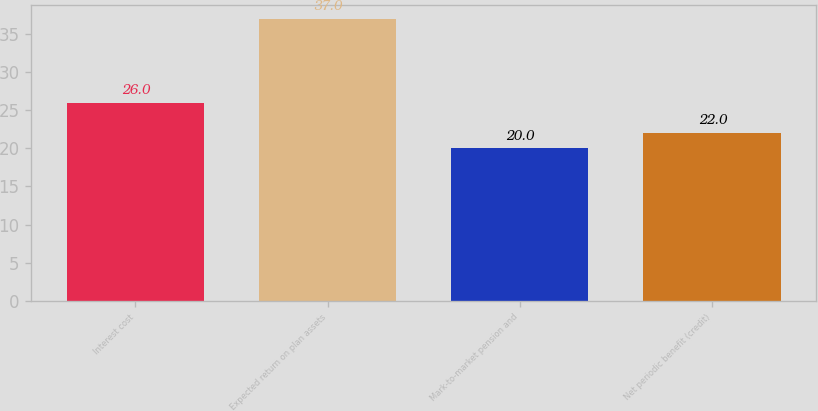Convert chart. <chart><loc_0><loc_0><loc_500><loc_500><bar_chart><fcel>Interest cost<fcel>Expected return on plan assets<fcel>Mark-to-market pension and<fcel>Net periodic benefit (credit)<nl><fcel>26<fcel>37<fcel>20<fcel>22<nl></chart> 